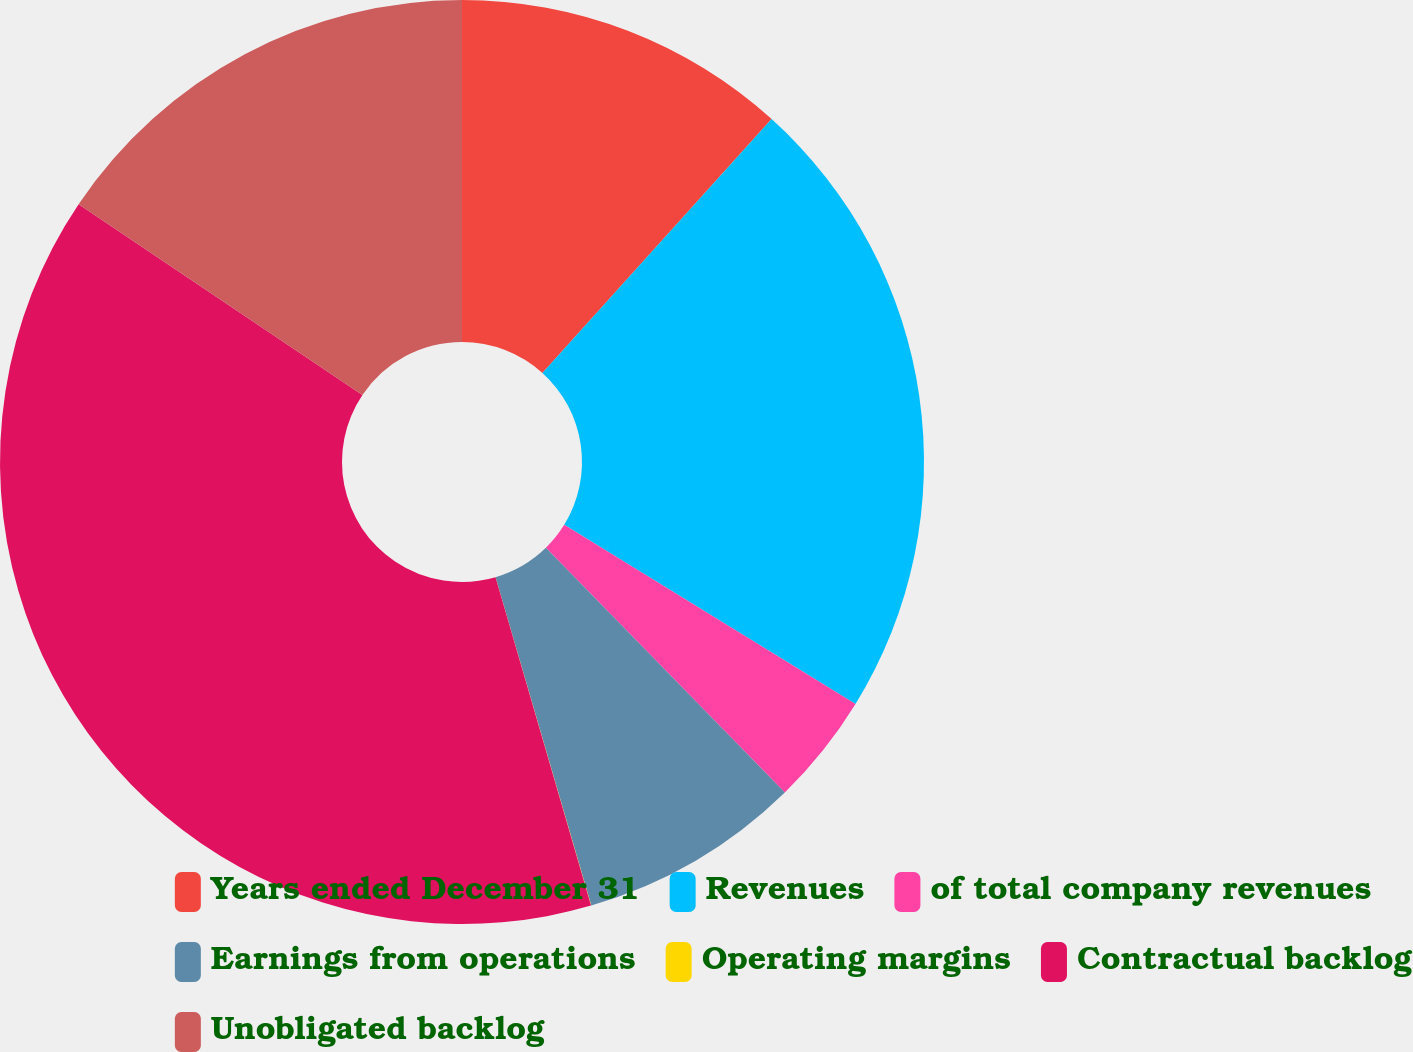Convert chart to OTSL. <chart><loc_0><loc_0><loc_500><loc_500><pie_chart><fcel>Years ended December 31<fcel>Revenues<fcel>of total company revenues<fcel>Earnings from operations<fcel>Operating margins<fcel>Contractual backlog<fcel>Unobligated backlog<nl><fcel>11.69%<fcel>22.09%<fcel>3.91%<fcel>7.8%<fcel>0.01%<fcel>38.93%<fcel>15.58%<nl></chart> 